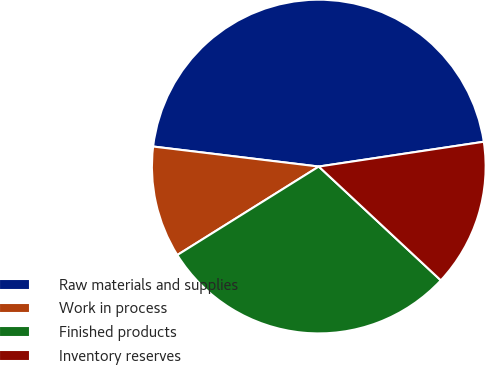Convert chart to OTSL. <chart><loc_0><loc_0><loc_500><loc_500><pie_chart><fcel>Raw materials and supplies<fcel>Work in process<fcel>Finished products<fcel>Inventory reserves<nl><fcel>45.71%<fcel>10.81%<fcel>29.16%<fcel>14.32%<nl></chart> 